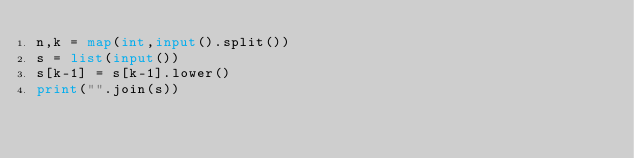<code> <loc_0><loc_0><loc_500><loc_500><_Python_>n,k = map(int,input().split())
s = list(input())
s[k-1] = s[k-1].lower()
print("".join(s))</code> 